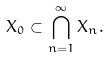Convert formula to latex. <formula><loc_0><loc_0><loc_500><loc_500>X _ { 0 } \subset \bigcap _ { n = 1 } ^ { \infty } X _ { n } .</formula> 